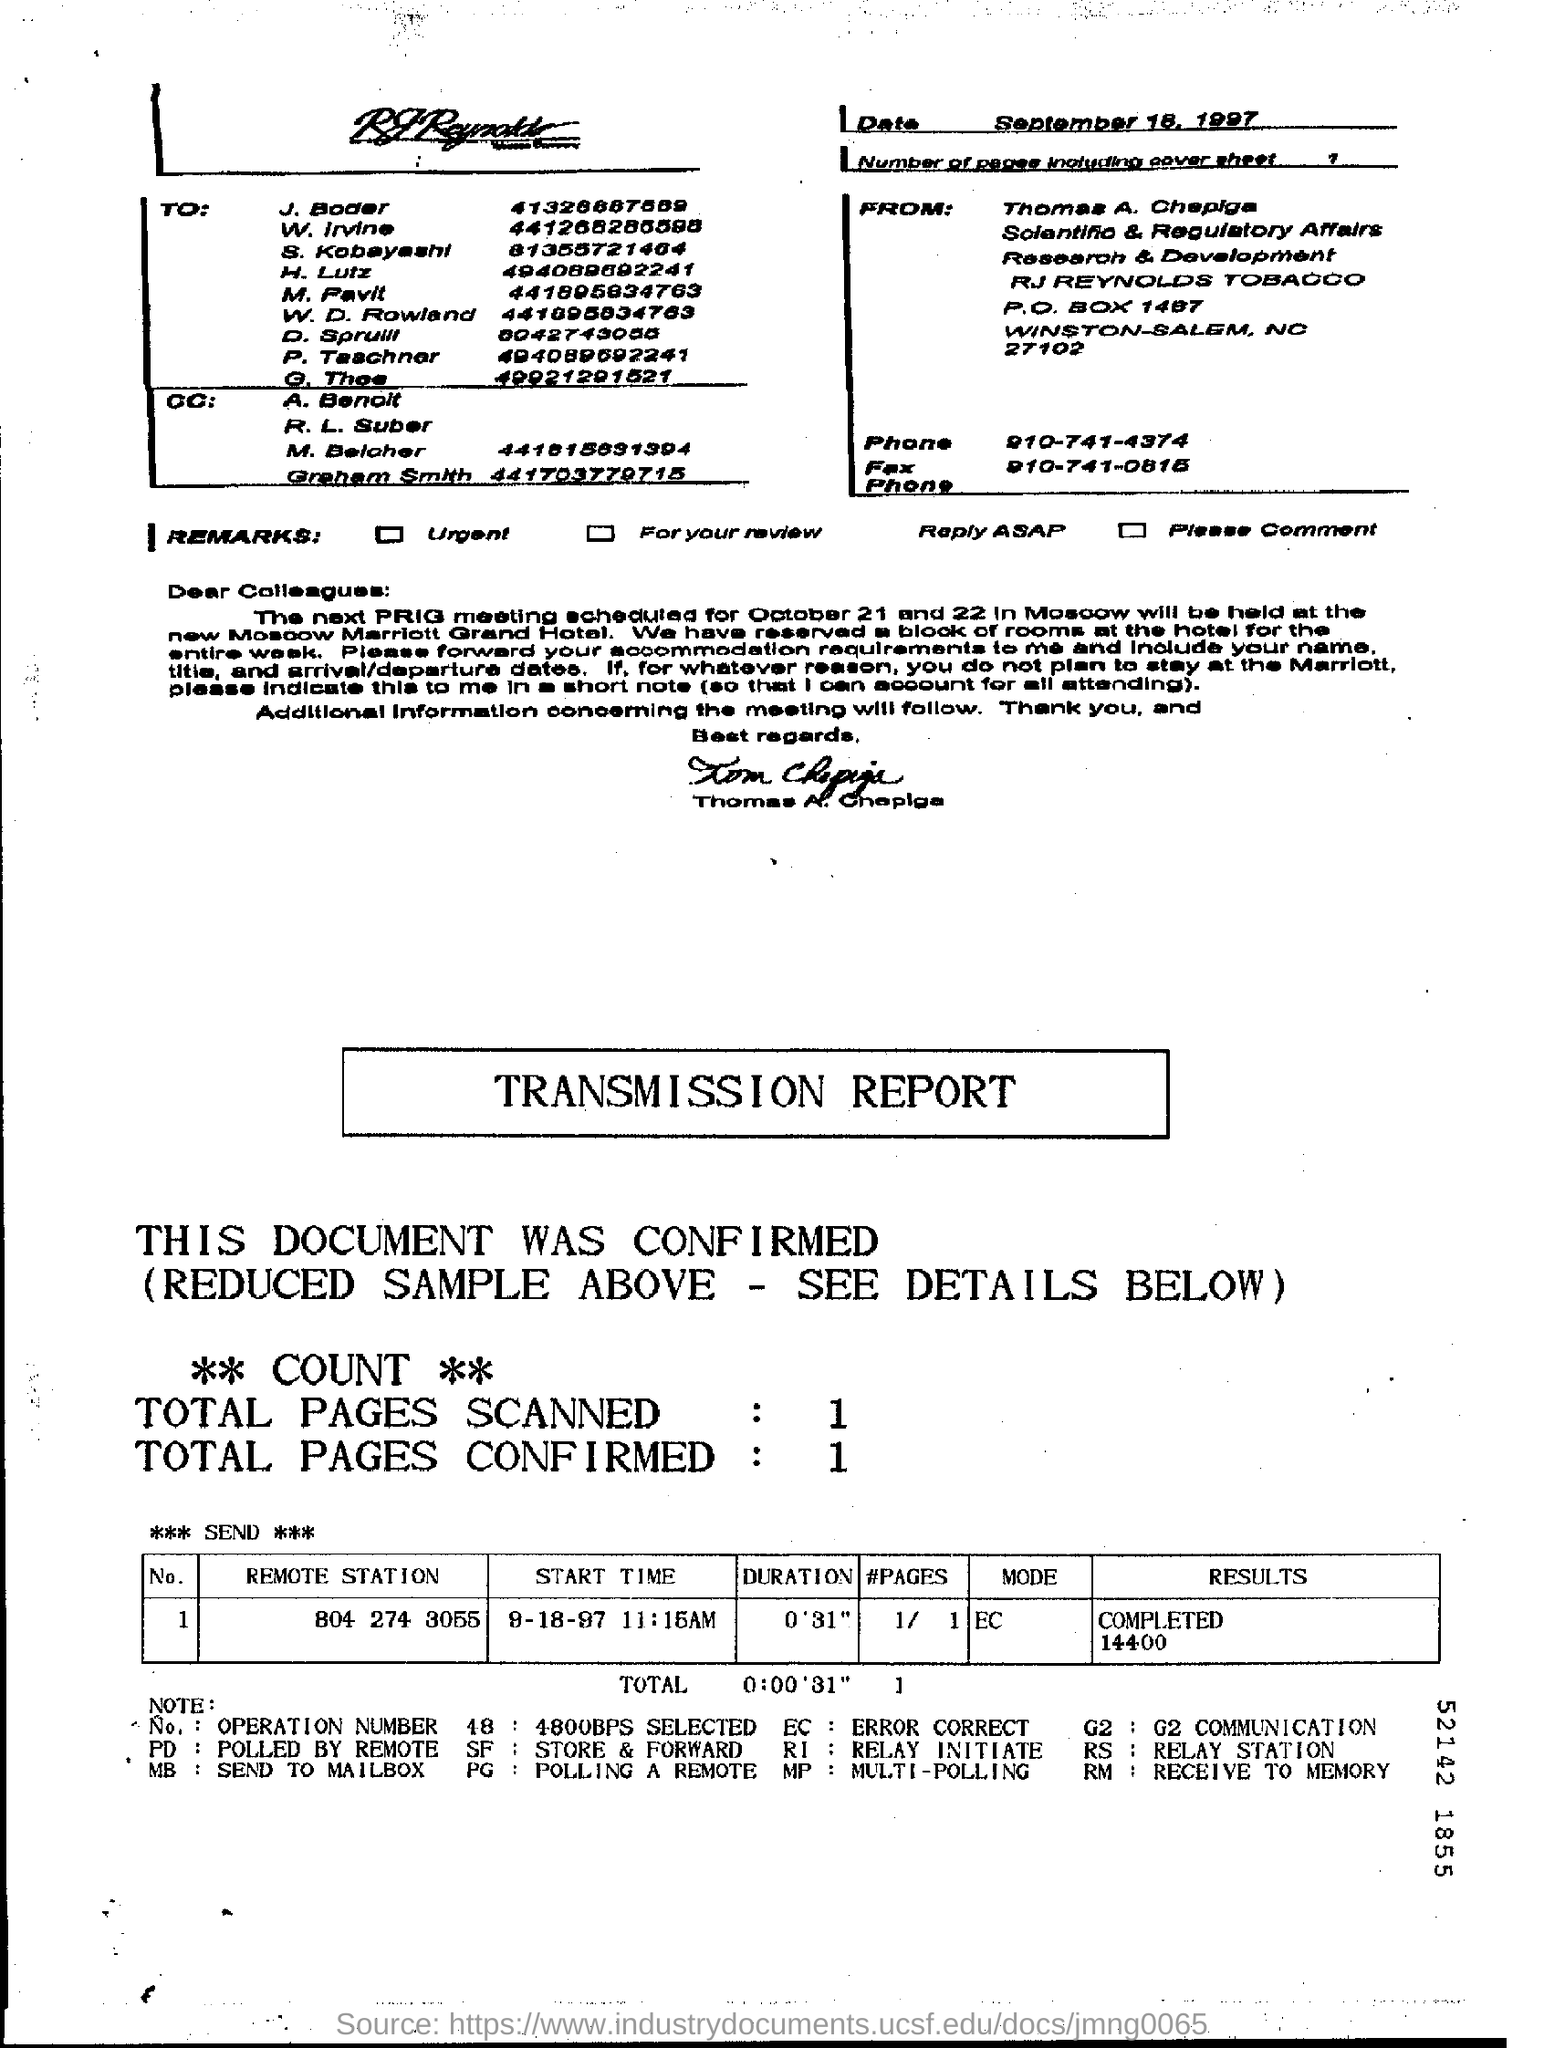List a handful of essential elements in this visual. The total number of pages scanned is 1... The number of pages, including the cover sheet, is 1. 